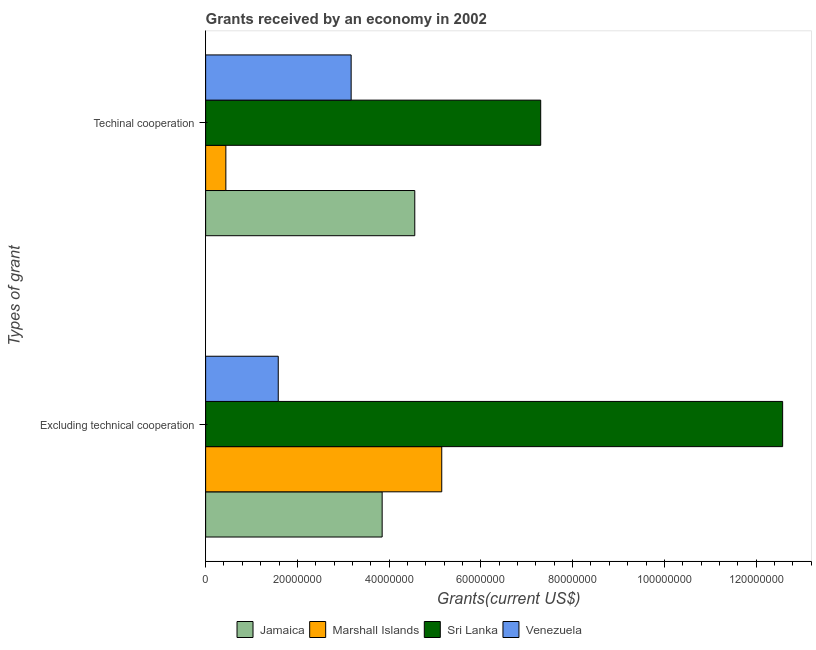How many different coloured bars are there?
Provide a succinct answer. 4. Are the number of bars on each tick of the Y-axis equal?
Provide a succinct answer. Yes. How many bars are there on the 2nd tick from the bottom?
Offer a very short reply. 4. What is the label of the 1st group of bars from the top?
Your answer should be very brief. Techinal cooperation. What is the amount of grants received(excluding technical cooperation) in Sri Lanka?
Your answer should be compact. 1.26e+08. Across all countries, what is the maximum amount of grants received(including technical cooperation)?
Provide a short and direct response. 7.30e+07. Across all countries, what is the minimum amount of grants received(including technical cooperation)?
Ensure brevity in your answer.  4.41e+06. In which country was the amount of grants received(including technical cooperation) maximum?
Your answer should be compact. Sri Lanka. In which country was the amount of grants received(including technical cooperation) minimum?
Offer a terse response. Marshall Islands. What is the total amount of grants received(including technical cooperation) in the graph?
Keep it short and to the point. 1.55e+08. What is the difference between the amount of grants received(excluding technical cooperation) in Venezuela and that in Sri Lanka?
Your answer should be compact. -1.10e+08. What is the difference between the amount of grants received(including technical cooperation) in Venezuela and the amount of grants received(excluding technical cooperation) in Jamaica?
Your response must be concise. -6.76e+06. What is the average amount of grants received(including technical cooperation) per country?
Ensure brevity in your answer.  3.87e+07. What is the difference between the amount of grants received(excluding technical cooperation) and amount of grants received(including technical cooperation) in Sri Lanka?
Make the answer very short. 5.27e+07. What is the ratio of the amount of grants received(excluding technical cooperation) in Marshall Islands to that in Venezuela?
Your response must be concise. 3.25. In how many countries, is the amount of grants received(excluding technical cooperation) greater than the average amount of grants received(excluding technical cooperation) taken over all countries?
Keep it short and to the point. 1. What does the 4th bar from the top in Techinal cooperation represents?
Provide a short and direct response. Jamaica. What does the 1st bar from the bottom in Techinal cooperation represents?
Provide a succinct answer. Jamaica. Are the values on the major ticks of X-axis written in scientific E-notation?
Your answer should be compact. No. Does the graph contain any zero values?
Your answer should be very brief. No. Does the graph contain grids?
Keep it short and to the point. No. What is the title of the graph?
Ensure brevity in your answer.  Grants received by an economy in 2002. Does "High income" appear as one of the legend labels in the graph?
Ensure brevity in your answer.  No. What is the label or title of the X-axis?
Your response must be concise. Grants(current US$). What is the label or title of the Y-axis?
Make the answer very short. Types of grant. What is the Grants(current US$) in Jamaica in Excluding technical cooperation?
Ensure brevity in your answer.  3.85e+07. What is the Grants(current US$) of Marshall Islands in Excluding technical cooperation?
Ensure brevity in your answer.  5.15e+07. What is the Grants(current US$) of Sri Lanka in Excluding technical cooperation?
Your answer should be compact. 1.26e+08. What is the Grants(current US$) of Venezuela in Excluding technical cooperation?
Give a very brief answer. 1.58e+07. What is the Grants(current US$) in Jamaica in Techinal cooperation?
Your response must be concise. 4.56e+07. What is the Grants(current US$) of Marshall Islands in Techinal cooperation?
Make the answer very short. 4.41e+06. What is the Grants(current US$) in Sri Lanka in Techinal cooperation?
Provide a short and direct response. 7.30e+07. What is the Grants(current US$) of Venezuela in Techinal cooperation?
Keep it short and to the point. 3.17e+07. Across all Types of grant, what is the maximum Grants(current US$) of Jamaica?
Your answer should be very brief. 4.56e+07. Across all Types of grant, what is the maximum Grants(current US$) of Marshall Islands?
Provide a short and direct response. 5.15e+07. Across all Types of grant, what is the maximum Grants(current US$) of Sri Lanka?
Your answer should be very brief. 1.26e+08. Across all Types of grant, what is the maximum Grants(current US$) in Venezuela?
Keep it short and to the point. 3.17e+07. Across all Types of grant, what is the minimum Grants(current US$) of Jamaica?
Make the answer very short. 3.85e+07. Across all Types of grant, what is the minimum Grants(current US$) of Marshall Islands?
Give a very brief answer. 4.41e+06. Across all Types of grant, what is the minimum Grants(current US$) of Sri Lanka?
Your answer should be compact. 7.30e+07. Across all Types of grant, what is the minimum Grants(current US$) of Venezuela?
Give a very brief answer. 1.58e+07. What is the total Grants(current US$) of Jamaica in the graph?
Your answer should be very brief. 8.41e+07. What is the total Grants(current US$) of Marshall Islands in the graph?
Your answer should be very brief. 5.59e+07. What is the total Grants(current US$) of Sri Lanka in the graph?
Your answer should be very brief. 1.99e+08. What is the total Grants(current US$) of Venezuela in the graph?
Keep it short and to the point. 4.76e+07. What is the difference between the Grants(current US$) of Jamaica in Excluding technical cooperation and that in Techinal cooperation?
Provide a succinct answer. -7.11e+06. What is the difference between the Grants(current US$) of Marshall Islands in Excluding technical cooperation and that in Techinal cooperation?
Your answer should be very brief. 4.71e+07. What is the difference between the Grants(current US$) of Sri Lanka in Excluding technical cooperation and that in Techinal cooperation?
Make the answer very short. 5.27e+07. What is the difference between the Grants(current US$) in Venezuela in Excluding technical cooperation and that in Techinal cooperation?
Your response must be concise. -1.59e+07. What is the difference between the Grants(current US$) of Jamaica in Excluding technical cooperation and the Grants(current US$) of Marshall Islands in Techinal cooperation?
Provide a short and direct response. 3.41e+07. What is the difference between the Grants(current US$) of Jamaica in Excluding technical cooperation and the Grants(current US$) of Sri Lanka in Techinal cooperation?
Your answer should be very brief. -3.46e+07. What is the difference between the Grants(current US$) of Jamaica in Excluding technical cooperation and the Grants(current US$) of Venezuela in Techinal cooperation?
Provide a short and direct response. 6.76e+06. What is the difference between the Grants(current US$) of Marshall Islands in Excluding technical cooperation and the Grants(current US$) of Sri Lanka in Techinal cooperation?
Make the answer very short. -2.16e+07. What is the difference between the Grants(current US$) of Marshall Islands in Excluding technical cooperation and the Grants(current US$) of Venezuela in Techinal cooperation?
Your response must be concise. 1.98e+07. What is the difference between the Grants(current US$) of Sri Lanka in Excluding technical cooperation and the Grants(current US$) of Venezuela in Techinal cooperation?
Offer a terse response. 9.41e+07. What is the average Grants(current US$) in Jamaica per Types of grant?
Ensure brevity in your answer.  4.20e+07. What is the average Grants(current US$) of Marshall Islands per Types of grant?
Offer a very short reply. 2.79e+07. What is the average Grants(current US$) in Sri Lanka per Types of grant?
Your answer should be compact. 9.94e+07. What is the average Grants(current US$) of Venezuela per Types of grant?
Keep it short and to the point. 2.38e+07. What is the difference between the Grants(current US$) of Jamaica and Grants(current US$) of Marshall Islands in Excluding technical cooperation?
Give a very brief answer. -1.30e+07. What is the difference between the Grants(current US$) in Jamaica and Grants(current US$) in Sri Lanka in Excluding technical cooperation?
Provide a succinct answer. -8.73e+07. What is the difference between the Grants(current US$) of Jamaica and Grants(current US$) of Venezuela in Excluding technical cooperation?
Your answer should be compact. 2.26e+07. What is the difference between the Grants(current US$) of Marshall Islands and Grants(current US$) of Sri Lanka in Excluding technical cooperation?
Your response must be concise. -7.43e+07. What is the difference between the Grants(current US$) in Marshall Islands and Grants(current US$) in Venezuela in Excluding technical cooperation?
Provide a succinct answer. 3.56e+07. What is the difference between the Grants(current US$) in Sri Lanka and Grants(current US$) in Venezuela in Excluding technical cooperation?
Your response must be concise. 1.10e+08. What is the difference between the Grants(current US$) in Jamaica and Grants(current US$) in Marshall Islands in Techinal cooperation?
Offer a very short reply. 4.12e+07. What is the difference between the Grants(current US$) in Jamaica and Grants(current US$) in Sri Lanka in Techinal cooperation?
Your response must be concise. -2.74e+07. What is the difference between the Grants(current US$) in Jamaica and Grants(current US$) in Venezuela in Techinal cooperation?
Offer a very short reply. 1.39e+07. What is the difference between the Grants(current US$) in Marshall Islands and Grants(current US$) in Sri Lanka in Techinal cooperation?
Your answer should be very brief. -6.86e+07. What is the difference between the Grants(current US$) of Marshall Islands and Grants(current US$) of Venezuela in Techinal cooperation?
Keep it short and to the point. -2.73e+07. What is the difference between the Grants(current US$) of Sri Lanka and Grants(current US$) of Venezuela in Techinal cooperation?
Your answer should be very brief. 4.13e+07. What is the ratio of the Grants(current US$) in Jamaica in Excluding technical cooperation to that in Techinal cooperation?
Provide a succinct answer. 0.84. What is the ratio of the Grants(current US$) in Marshall Islands in Excluding technical cooperation to that in Techinal cooperation?
Your answer should be compact. 11.67. What is the ratio of the Grants(current US$) in Sri Lanka in Excluding technical cooperation to that in Techinal cooperation?
Give a very brief answer. 1.72. What is the ratio of the Grants(current US$) of Venezuela in Excluding technical cooperation to that in Techinal cooperation?
Keep it short and to the point. 0.5. What is the difference between the highest and the second highest Grants(current US$) of Jamaica?
Make the answer very short. 7.11e+06. What is the difference between the highest and the second highest Grants(current US$) of Marshall Islands?
Make the answer very short. 4.71e+07. What is the difference between the highest and the second highest Grants(current US$) in Sri Lanka?
Make the answer very short. 5.27e+07. What is the difference between the highest and the second highest Grants(current US$) in Venezuela?
Ensure brevity in your answer.  1.59e+07. What is the difference between the highest and the lowest Grants(current US$) of Jamaica?
Offer a terse response. 7.11e+06. What is the difference between the highest and the lowest Grants(current US$) in Marshall Islands?
Offer a very short reply. 4.71e+07. What is the difference between the highest and the lowest Grants(current US$) of Sri Lanka?
Give a very brief answer. 5.27e+07. What is the difference between the highest and the lowest Grants(current US$) in Venezuela?
Provide a succinct answer. 1.59e+07. 